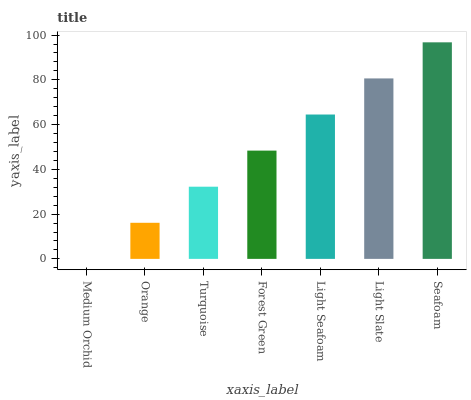Is Orange the minimum?
Answer yes or no. No. Is Orange the maximum?
Answer yes or no. No. Is Orange greater than Medium Orchid?
Answer yes or no. Yes. Is Medium Orchid less than Orange?
Answer yes or no. Yes. Is Medium Orchid greater than Orange?
Answer yes or no. No. Is Orange less than Medium Orchid?
Answer yes or no. No. Is Forest Green the high median?
Answer yes or no. Yes. Is Forest Green the low median?
Answer yes or no. Yes. Is Medium Orchid the high median?
Answer yes or no. No. Is Light Seafoam the low median?
Answer yes or no. No. 